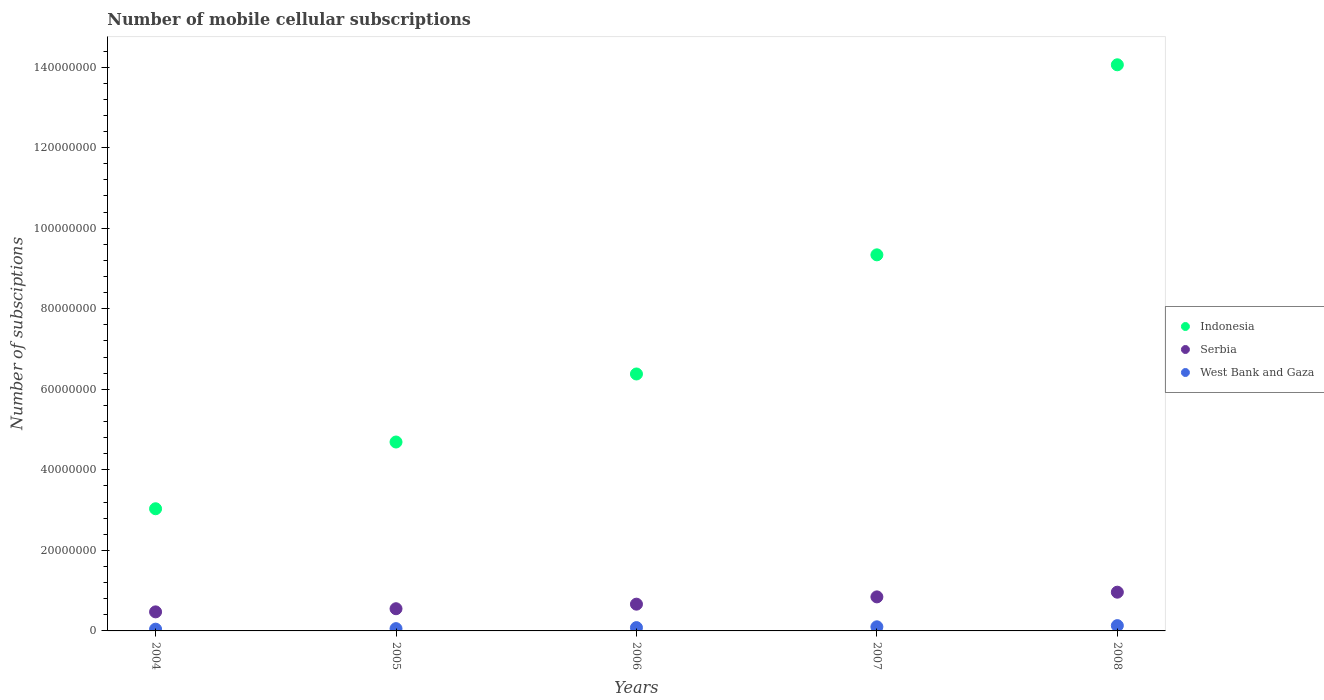How many different coloured dotlines are there?
Make the answer very short. 3. Is the number of dotlines equal to the number of legend labels?
Your answer should be very brief. Yes. What is the number of mobile cellular subscriptions in Serbia in 2004?
Your answer should be compact. 4.73e+06. Across all years, what is the maximum number of mobile cellular subscriptions in Indonesia?
Ensure brevity in your answer.  1.41e+08. Across all years, what is the minimum number of mobile cellular subscriptions in Serbia?
Provide a short and direct response. 4.73e+06. In which year was the number of mobile cellular subscriptions in West Bank and Gaza maximum?
Offer a very short reply. 2008. In which year was the number of mobile cellular subscriptions in West Bank and Gaza minimum?
Offer a terse response. 2004. What is the total number of mobile cellular subscriptions in Serbia in the graph?
Provide a short and direct response. 3.50e+07. What is the difference between the number of mobile cellular subscriptions in Indonesia in 2005 and that in 2006?
Provide a short and direct response. -1.69e+07. What is the difference between the number of mobile cellular subscriptions in Indonesia in 2005 and the number of mobile cellular subscriptions in Serbia in 2008?
Provide a succinct answer. 3.73e+07. What is the average number of mobile cellular subscriptions in Serbia per year?
Offer a terse response. 6.99e+06. In the year 2007, what is the difference between the number of mobile cellular subscriptions in West Bank and Gaza and number of mobile cellular subscriptions in Serbia?
Your answer should be very brief. -7.43e+06. What is the ratio of the number of mobile cellular subscriptions in Serbia in 2005 to that in 2007?
Give a very brief answer. 0.65. What is the difference between the highest and the second highest number of mobile cellular subscriptions in West Bank and Gaza?
Your answer should be compact. 2.93e+05. What is the difference between the highest and the lowest number of mobile cellular subscriptions in West Bank and Gaza?
Your answer should be very brief. 8.78e+05. In how many years, is the number of mobile cellular subscriptions in Serbia greater than the average number of mobile cellular subscriptions in Serbia taken over all years?
Make the answer very short. 2. Is the number of mobile cellular subscriptions in Serbia strictly greater than the number of mobile cellular subscriptions in Indonesia over the years?
Provide a short and direct response. No. What is the difference between two consecutive major ticks on the Y-axis?
Keep it short and to the point. 2.00e+07. Does the graph contain any zero values?
Your answer should be compact. No. Where does the legend appear in the graph?
Your response must be concise. Center right. What is the title of the graph?
Your response must be concise. Number of mobile cellular subscriptions. Does "Iceland" appear as one of the legend labels in the graph?
Offer a very short reply. No. What is the label or title of the Y-axis?
Provide a short and direct response. Number of subsciptions. What is the Number of subsciptions in Indonesia in 2004?
Ensure brevity in your answer.  3.03e+07. What is the Number of subsciptions of Serbia in 2004?
Your answer should be compact. 4.73e+06. What is the Number of subsciptions of West Bank and Gaza in 2004?
Offer a terse response. 4.37e+05. What is the Number of subsciptions in Indonesia in 2005?
Ensure brevity in your answer.  4.69e+07. What is the Number of subsciptions of Serbia in 2005?
Give a very brief answer. 5.51e+06. What is the Number of subsciptions of West Bank and Gaza in 2005?
Give a very brief answer. 5.68e+05. What is the Number of subsciptions of Indonesia in 2006?
Give a very brief answer. 6.38e+07. What is the Number of subsciptions of Serbia in 2006?
Offer a terse response. 6.64e+06. What is the Number of subsciptions in West Bank and Gaza in 2006?
Provide a succinct answer. 8.22e+05. What is the Number of subsciptions in Indonesia in 2007?
Provide a succinct answer. 9.34e+07. What is the Number of subsciptions of Serbia in 2007?
Provide a short and direct response. 8.45e+06. What is the Number of subsciptions of West Bank and Gaza in 2007?
Keep it short and to the point. 1.02e+06. What is the Number of subsciptions of Indonesia in 2008?
Offer a very short reply. 1.41e+08. What is the Number of subsciptions of Serbia in 2008?
Provide a succinct answer. 9.62e+06. What is the Number of subsciptions of West Bank and Gaza in 2008?
Provide a short and direct response. 1.31e+06. Across all years, what is the maximum Number of subsciptions in Indonesia?
Offer a very short reply. 1.41e+08. Across all years, what is the maximum Number of subsciptions of Serbia?
Provide a succinct answer. 9.62e+06. Across all years, what is the maximum Number of subsciptions of West Bank and Gaza?
Your answer should be very brief. 1.31e+06. Across all years, what is the minimum Number of subsciptions of Indonesia?
Make the answer very short. 3.03e+07. Across all years, what is the minimum Number of subsciptions of Serbia?
Provide a short and direct response. 4.73e+06. Across all years, what is the minimum Number of subsciptions in West Bank and Gaza?
Your response must be concise. 4.37e+05. What is the total Number of subsciptions in Indonesia in the graph?
Keep it short and to the point. 3.75e+08. What is the total Number of subsciptions of Serbia in the graph?
Provide a short and direct response. 3.50e+07. What is the total Number of subsciptions in West Bank and Gaza in the graph?
Ensure brevity in your answer.  4.16e+06. What is the difference between the Number of subsciptions in Indonesia in 2004 and that in 2005?
Your answer should be very brief. -1.66e+07. What is the difference between the Number of subsciptions in Serbia in 2004 and that in 2005?
Ensure brevity in your answer.  -7.81e+05. What is the difference between the Number of subsciptions in West Bank and Gaza in 2004 and that in 2005?
Keep it short and to the point. -1.31e+05. What is the difference between the Number of subsciptions in Indonesia in 2004 and that in 2006?
Your answer should be compact. -3.35e+07. What is the difference between the Number of subsciptions in Serbia in 2004 and that in 2006?
Your answer should be compact. -1.91e+06. What is the difference between the Number of subsciptions in West Bank and Gaza in 2004 and that in 2006?
Your answer should be very brief. -3.85e+05. What is the difference between the Number of subsciptions in Indonesia in 2004 and that in 2007?
Offer a terse response. -6.31e+07. What is the difference between the Number of subsciptions of Serbia in 2004 and that in 2007?
Keep it short and to the point. -3.72e+06. What is the difference between the Number of subsciptions in West Bank and Gaza in 2004 and that in 2007?
Provide a succinct answer. -5.85e+05. What is the difference between the Number of subsciptions in Indonesia in 2004 and that in 2008?
Keep it short and to the point. -1.10e+08. What is the difference between the Number of subsciptions of Serbia in 2004 and that in 2008?
Provide a succinct answer. -4.89e+06. What is the difference between the Number of subsciptions of West Bank and Gaza in 2004 and that in 2008?
Your answer should be compact. -8.78e+05. What is the difference between the Number of subsciptions of Indonesia in 2005 and that in 2006?
Your response must be concise. -1.69e+07. What is the difference between the Number of subsciptions in Serbia in 2005 and that in 2006?
Provide a succinct answer. -1.13e+06. What is the difference between the Number of subsciptions of West Bank and Gaza in 2005 and that in 2006?
Provide a succinct answer. -2.54e+05. What is the difference between the Number of subsciptions in Indonesia in 2005 and that in 2007?
Give a very brief answer. -4.65e+07. What is the difference between the Number of subsciptions of Serbia in 2005 and that in 2007?
Provide a succinct answer. -2.94e+06. What is the difference between the Number of subsciptions of West Bank and Gaza in 2005 and that in 2007?
Offer a very short reply. -4.54e+05. What is the difference between the Number of subsciptions of Indonesia in 2005 and that in 2008?
Make the answer very short. -9.37e+07. What is the difference between the Number of subsciptions in Serbia in 2005 and that in 2008?
Your answer should be very brief. -4.11e+06. What is the difference between the Number of subsciptions of West Bank and Gaza in 2005 and that in 2008?
Make the answer very short. -7.47e+05. What is the difference between the Number of subsciptions of Indonesia in 2006 and that in 2007?
Give a very brief answer. -2.96e+07. What is the difference between the Number of subsciptions in Serbia in 2006 and that in 2007?
Your answer should be very brief. -1.81e+06. What is the difference between the Number of subsciptions of West Bank and Gaza in 2006 and that in 2007?
Ensure brevity in your answer.  -2.00e+05. What is the difference between the Number of subsciptions of Indonesia in 2006 and that in 2008?
Your answer should be compact. -7.68e+07. What is the difference between the Number of subsciptions of Serbia in 2006 and that in 2008?
Keep it short and to the point. -2.98e+06. What is the difference between the Number of subsciptions in West Bank and Gaza in 2006 and that in 2008?
Make the answer very short. -4.93e+05. What is the difference between the Number of subsciptions in Indonesia in 2007 and that in 2008?
Offer a terse response. -4.72e+07. What is the difference between the Number of subsciptions of Serbia in 2007 and that in 2008?
Provide a succinct answer. -1.17e+06. What is the difference between the Number of subsciptions in West Bank and Gaza in 2007 and that in 2008?
Offer a very short reply. -2.93e+05. What is the difference between the Number of subsciptions of Indonesia in 2004 and the Number of subsciptions of Serbia in 2005?
Your answer should be compact. 2.48e+07. What is the difference between the Number of subsciptions of Indonesia in 2004 and the Number of subsciptions of West Bank and Gaza in 2005?
Your answer should be compact. 2.98e+07. What is the difference between the Number of subsciptions of Serbia in 2004 and the Number of subsciptions of West Bank and Gaza in 2005?
Keep it short and to the point. 4.16e+06. What is the difference between the Number of subsciptions of Indonesia in 2004 and the Number of subsciptions of Serbia in 2006?
Your answer should be very brief. 2.37e+07. What is the difference between the Number of subsciptions in Indonesia in 2004 and the Number of subsciptions in West Bank and Gaza in 2006?
Offer a terse response. 2.95e+07. What is the difference between the Number of subsciptions of Serbia in 2004 and the Number of subsciptions of West Bank and Gaza in 2006?
Your answer should be compact. 3.91e+06. What is the difference between the Number of subsciptions of Indonesia in 2004 and the Number of subsciptions of Serbia in 2007?
Offer a very short reply. 2.19e+07. What is the difference between the Number of subsciptions of Indonesia in 2004 and the Number of subsciptions of West Bank and Gaza in 2007?
Give a very brief answer. 2.93e+07. What is the difference between the Number of subsciptions in Serbia in 2004 and the Number of subsciptions in West Bank and Gaza in 2007?
Your answer should be compact. 3.71e+06. What is the difference between the Number of subsciptions in Indonesia in 2004 and the Number of subsciptions in Serbia in 2008?
Provide a succinct answer. 2.07e+07. What is the difference between the Number of subsciptions in Indonesia in 2004 and the Number of subsciptions in West Bank and Gaza in 2008?
Your response must be concise. 2.90e+07. What is the difference between the Number of subsciptions in Serbia in 2004 and the Number of subsciptions in West Bank and Gaza in 2008?
Make the answer very short. 3.42e+06. What is the difference between the Number of subsciptions in Indonesia in 2005 and the Number of subsciptions in Serbia in 2006?
Offer a terse response. 4.03e+07. What is the difference between the Number of subsciptions of Indonesia in 2005 and the Number of subsciptions of West Bank and Gaza in 2006?
Your answer should be compact. 4.61e+07. What is the difference between the Number of subsciptions in Serbia in 2005 and the Number of subsciptions in West Bank and Gaza in 2006?
Provide a succinct answer. 4.69e+06. What is the difference between the Number of subsciptions in Indonesia in 2005 and the Number of subsciptions in Serbia in 2007?
Ensure brevity in your answer.  3.85e+07. What is the difference between the Number of subsciptions in Indonesia in 2005 and the Number of subsciptions in West Bank and Gaza in 2007?
Give a very brief answer. 4.59e+07. What is the difference between the Number of subsciptions in Serbia in 2005 and the Number of subsciptions in West Bank and Gaza in 2007?
Keep it short and to the point. 4.49e+06. What is the difference between the Number of subsciptions of Indonesia in 2005 and the Number of subsciptions of Serbia in 2008?
Provide a short and direct response. 3.73e+07. What is the difference between the Number of subsciptions of Indonesia in 2005 and the Number of subsciptions of West Bank and Gaza in 2008?
Offer a terse response. 4.56e+07. What is the difference between the Number of subsciptions in Serbia in 2005 and the Number of subsciptions in West Bank and Gaza in 2008?
Ensure brevity in your answer.  4.20e+06. What is the difference between the Number of subsciptions in Indonesia in 2006 and the Number of subsciptions in Serbia in 2007?
Ensure brevity in your answer.  5.54e+07. What is the difference between the Number of subsciptions in Indonesia in 2006 and the Number of subsciptions in West Bank and Gaza in 2007?
Keep it short and to the point. 6.28e+07. What is the difference between the Number of subsciptions of Serbia in 2006 and the Number of subsciptions of West Bank and Gaza in 2007?
Your answer should be compact. 5.62e+06. What is the difference between the Number of subsciptions of Indonesia in 2006 and the Number of subsciptions of Serbia in 2008?
Your response must be concise. 5.42e+07. What is the difference between the Number of subsciptions of Indonesia in 2006 and the Number of subsciptions of West Bank and Gaza in 2008?
Make the answer very short. 6.25e+07. What is the difference between the Number of subsciptions in Serbia in 2006 and the Number of subsciptions in West Bank and Gaza in 2008?
Your answer should be compact. 5.33e+06. What is the difference between the Number of subsciptions in Indonesia in 2007 and the Number of subsciptions in Serbia in 2008?
Make the answer very short. 8.38e+07. What is the difference between the Number of subsciptions in Indonesia in 2007 and the Number of subsciptions in West Bank and Gaza in 2008?
Provide a succinct answer. 9.21e+07. What is the difference between the Number of subsciptions in Serbia in 2007 and the Number of subsciptions in West Bank and Gaza in 2008?
Provide a succinct answer. 7.14e+06. What is the average Number of subsciptions in Indonesia per year?
Make the answer very short. 7.50e+07. What is the average Number of subsciptions of Serbia per year?
Provide a succinct answer. 6.99e+06. What is the average Number of subsciptions of West Bank and Gaza per year?
Keep it short and to the point. 8.32e+05. In the year 2004, what is the difference between the Number of subsciptions of Indonesia and Number of subsciptions of Serbia?
Keep it short and to the point. 2.56e+07. In the year 2004, what is the difference between the Number of subsciptions of Indonesia and Number of subsciptions of West Bank and Gaza?
Your answer should be very brief. 2.99e+07. In the year 2004, what is the difference between the Number of subsciptions of Serbia and Number of subsciptions of West Bank and Gaza?
Your answer should be compact. 4.29e+06. In the year 2005, what is the difference between the Number of subsciptions in Indonesia and Number of subsciptions in Serbia?
Offer a terse response. 4.14e+07. In the year 2005, what is the difference between the Number of subsciptions in Indonesia and Number of subsciptions in West Bank and Gaza?
Offer a terse response. 4.63e+07. In the year 2005, what is the difference between the Number of subsciptions of Serbia and Number of subsciptions of West Bank and Gaza?
Provide a short and direct response. 4.94e+06. In the year 2006, what is the difference between the Number of subsciptions of Indonesia and Number of subsciptions of Serbia?
Offer a very short reply. 5.72e+07. In the year 2006, what is the difference between the Number of subsciptions of Indonesia and Number of subsciptions of West Bank and Gaza?
Keep it short and to the point. 6.30e+07. In the year 2006, what is the difference between the Number of subsciptions of Serbia and Number of subsciptions of West Bank and Gaza?
Provide a succinct answer. 5.82e+06. In the year 2007, what is the difference between the Number of subsciptions of Indonesia and Number of subsciptions of Serbia?
Your response must be concise. 8.49e+07. In the year 2007, what is the difference between the Number of subsciptions in Indonesia and Number of subsciptions in West Bank and Gaza?
Your answer should be compact. 9.24e+07. In the year 2007, what is the difference between the Number of subsciptions of Serbia and Number of subsciptions of West Bank and Gaza?
Your answer should be compact. 7.43e+06. In the year 2008, what is the difference between the Number of subsciptions of Indonesia and Number of subsciptions of Serbia?
Offer a terse response. 1.31e+08. In the year 2008, what is the difference between the Number of subsciptions of Indonesia and Number of subsciptions of West Bank and Gaza?
Offer a terse response. 1.39e+08. In the year 2008, what is the difference between the Number of subsciptions of Serbia and Number of subsciptions of West Bank and Gaza?
Offer a terse response. 8.30e+06. What is the ratio of the Number of subsciptions of Indonesia in 2004 to that in 2005?
Your response must be concise. 0.65. What is the ratio of the Number of subsciptions in Serbia in 2004 to that in 2005?
Give a very brief answer. 0.86. What is the ratio of the Number of subsciptions of West Bank and Gaza in 2004 to that in 2005?
Ensure brevity in your answer.  0.77. What is the ratio of the Number of subsciptions of Indonesia in 2004 to that in 2006?
Give a very brief answer. 0.48. What is the ratio of the Number of subsciptions of Serbia in 2004 to that in 2006?
Give a very brief answer. 0.71. What is the ratio of the Number of subsciptions of West Bank and Gaza in 2004 to that in 2006?
Make the answer very short. 0.53. What is the ratio of the Number of subsciptions in Indonesia in 2004 to that in 2007?
Make the answer very short. 0.32. What is the ratio of the Number of subsciptions in Serbia in 2004 to that in 2007?
Make the answer very short. 0.56. What is the ratio of the Number of subsciptions in West Bank and Gaza in 2004 to that in 2007?
Offer a terse response. 0.43. What is the ratio of the Number of subsciptions of Indonesia in 2004 to that in 2008?
Your answer should be compact. 0.22. What is the ratio of the Number of subsciptions of Serbia in 2004 to that in 2008?
Offer a very short reply. 0.49. What is the ratio of the Number of subsciptions of West Bank and Gaza in 2004 to that in 2008?
Make the answer very short. 0.33. What is the ratio of the Number of subsciptions in Indonesia in 2005 to that in 2006?
Your answer should be compact. 0.74. What is the ratio of the Number of subsciptions of Serbia in 2005 to that in 2006?
Provide a succinct answer. 0.83. What is the ratio of the Number of subsciptions of West Bank and Gaza in 2005 to that in 2006?
Provide a succinct answer. 0.69. What is the ratio of the Number of subsciptions of Indonesia in 2005 to that in 2007?
Give a very brief answer. 0.5. What is the ratio of the Number of subsciptions in Serbia in 2005 to that in 2007?
Your answer should be compact. 0.65. What is the ratio of the Number of subsciptions in West Bank and Gaza in 2005 to that in 2007?
Keep it short and to the point. 0.56. What is the ratio of the Number of subsciptions of Indonesia in 2005 to that in 2008?
Give a very brief answer. 0.33. What is the ratio of the Number of subsciptions in Serbia in 2005 to that in 2008?
Offer a very short reply. 0.57. What is the ratio of the Number of subsciptions of West Bank and Gaza in 2005 to that in 2008?
Ensure brevity in your answer.  0.43. What is the ratio of the Number of subsciptions in Indonesia in 2006 to that in 2007?
Make the answer very short. 0.68. What is the ratio of the Number of subsciptions in Serbia in 2006 to that in 2007?
Give a very brief answer. 0.79. What is the ratio of the Number of subsciptions in West Bank and Gaza in 2006 to that in 2007?
Offer a terse response. 0.8. What is the ratio of the Number of subsciptions in Indonesia in 2006 to that in 2008?
Your response must be concise. 0.45. What is the ratio of the Number of subsciptions in Serbia in 2006 to that in 2008?
Give a very brief answer. 0.69. What is the ratio of the Number of subsciptions of West Bank and Gaza in 2006 to that in 2008?
Your response must be concise. 0.63. What is the ratio of the Number of subsciptions of Indonesia in 2007 to that in 2008?
Offer a very short reply. 0.66. What is the ratio of the Number of subsciptions in Serbia in 2007 to that in 2008?
Keep it short and to the point. 0.88. What is the ratio of the Number of subsciptions of West Bank and Gaza in 2007 to that in 2008?
Offer a very short reply. 0.78. What is the difference between the highest and the second highest Number of subsciptions in Indonesia?
Give a very brief answer. 4.72e+07. What is the difference between the highest and the second highest Number of subsciptions in Serbia?
Make the answer very short. 1.17e+06. What is the difference between the highest and the second highest Number of subsciptions in West Bank and Gaza?
Give a very brief answer. 2.93e+05. What is the difference between the highest and the lowest Number of subsciptions of Indonesia?
Offer a very short reply. 1.10e+08. What is the difference between the highest and the lowest Number of subsciptions of Serbia?
Your response must be concise. 4.89e+06. What is the difference between the highest and the lowest Number of subsciptions of West Bank and Gaza?
Provide a succinct answer. 8.78e+05. 